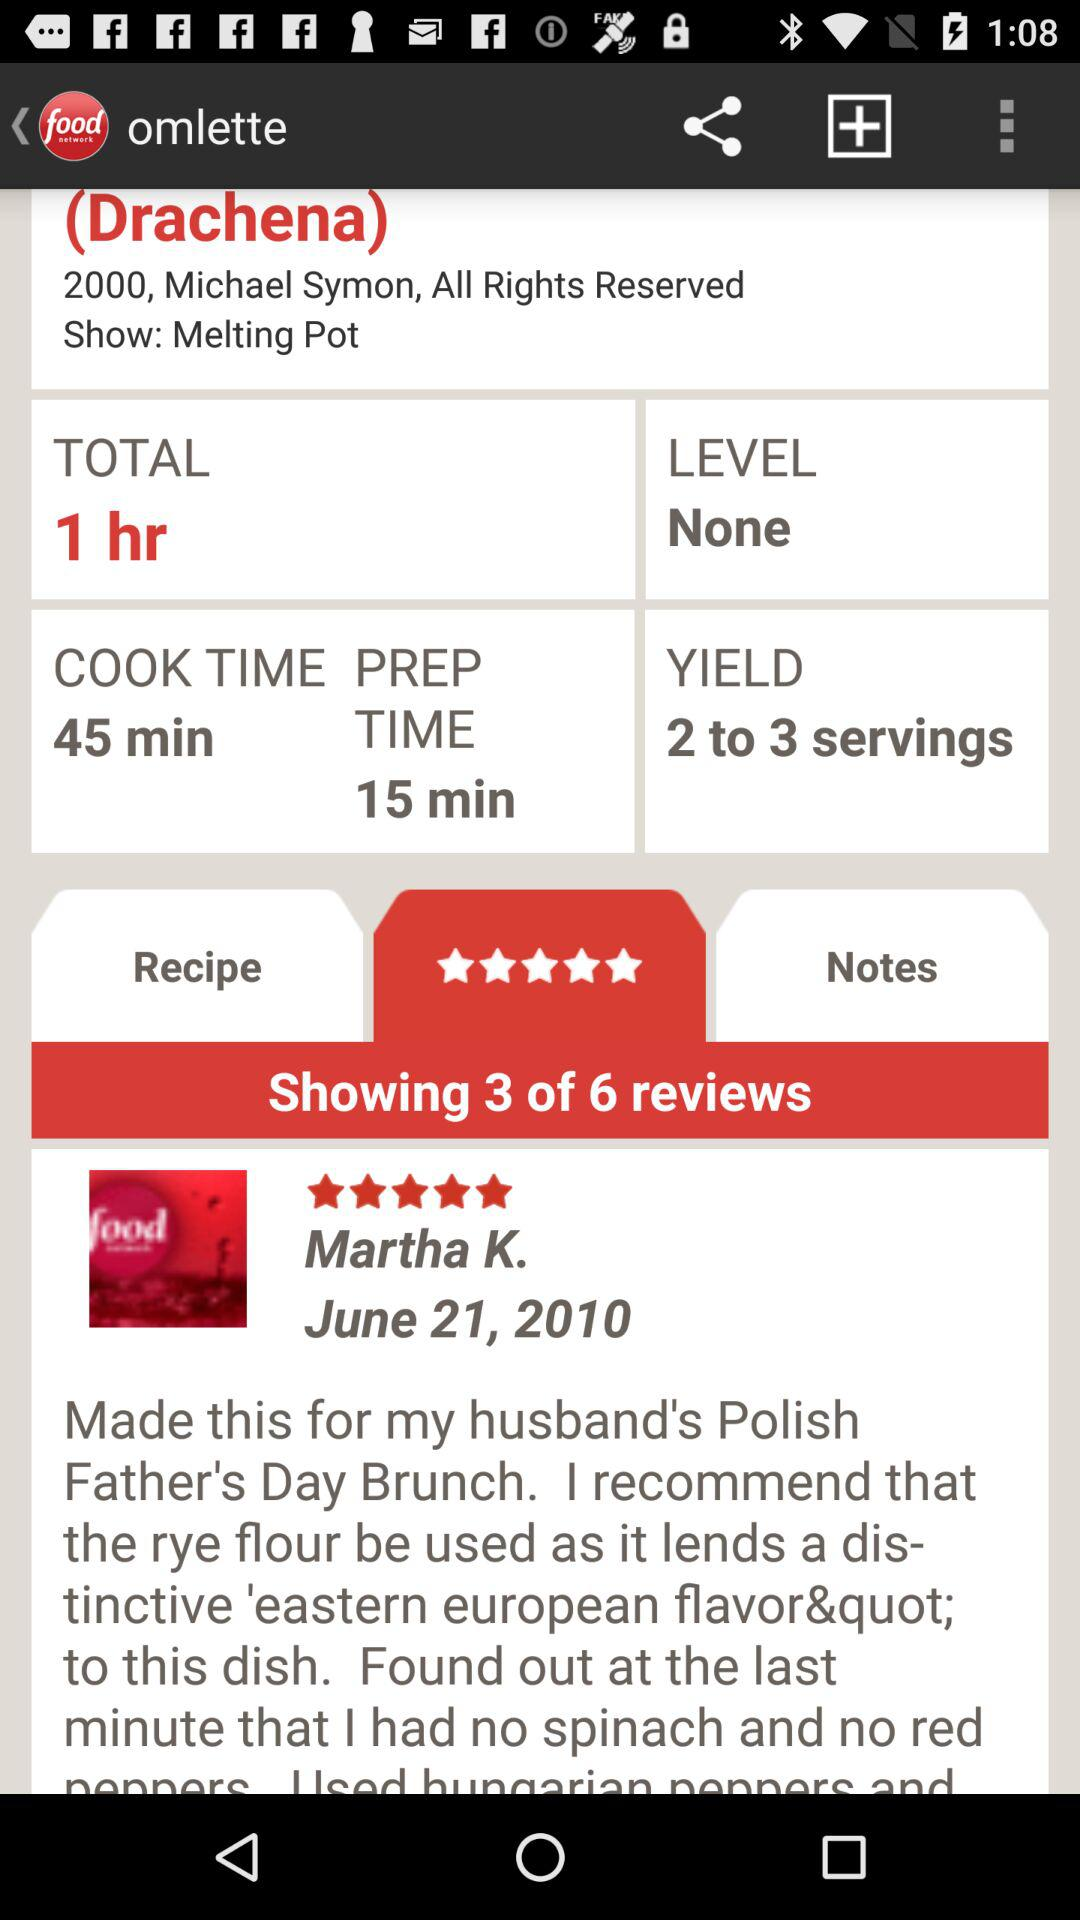What is the cooking time? The cooking time is 45 minutes. 